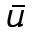Convert formula to latex. <formula><loc_0><loc_0><loc_500><loc_500>\bar { u }</formula> 